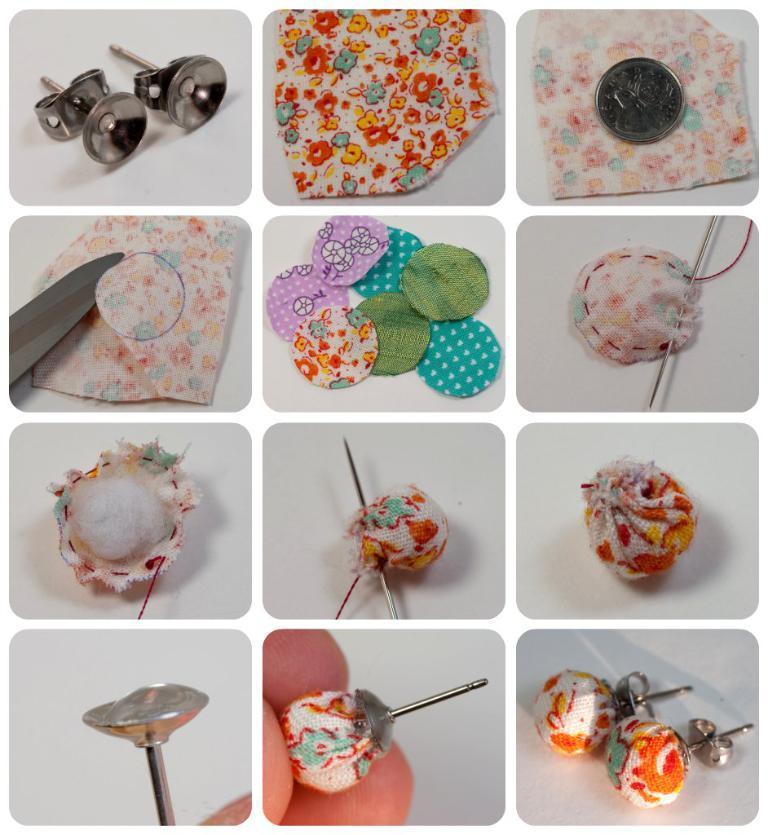Could you give a brief overview of what you see in this image? This picture is a collage of twelve images. In four images I can observe earrings and a pin. In two images I can observe a needle. In the remaining images I can observe cloth pieces coin and a knife. 